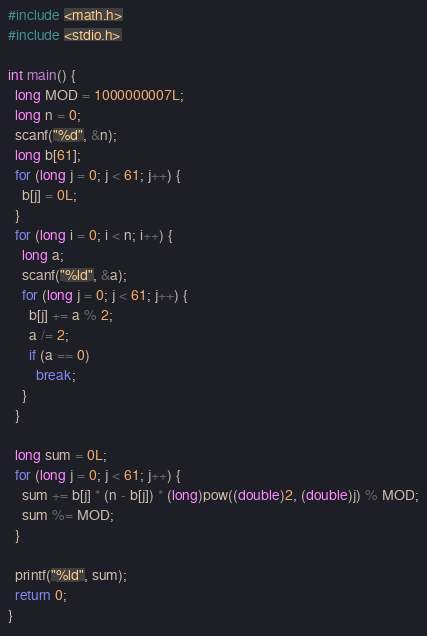Convert code to text. <code><loc_0><loc_0><loc_500><loc_500><_C_>#include <math.h>
#include <stdio.h>

int main() {
  long MOD = 1000000007L;
  long n = 0;
  scanf("%d", &n);
  long b[61];
  for (long j = 0; j < 61; j++) {
    b[j] = 0L;
  }
  for (long i = 0; i < n; i++) {
    long a;
    scanf("%ld", &a);
    for (long j = 0; j < 61; j++) {
      b[j] += a % 2;
      a /= 2;
      if (a == 0)
        break;
    }
  }

  long sum = 0L;
  for (long j = 0; j < 61; j++) {
    sum += b[j] * (n - b[j]) * (long)pow((double)2, (double)j) % MOD;
    sum %= MOD;
  }

  printf("%ld", sum);
  return 0;
}</code> 